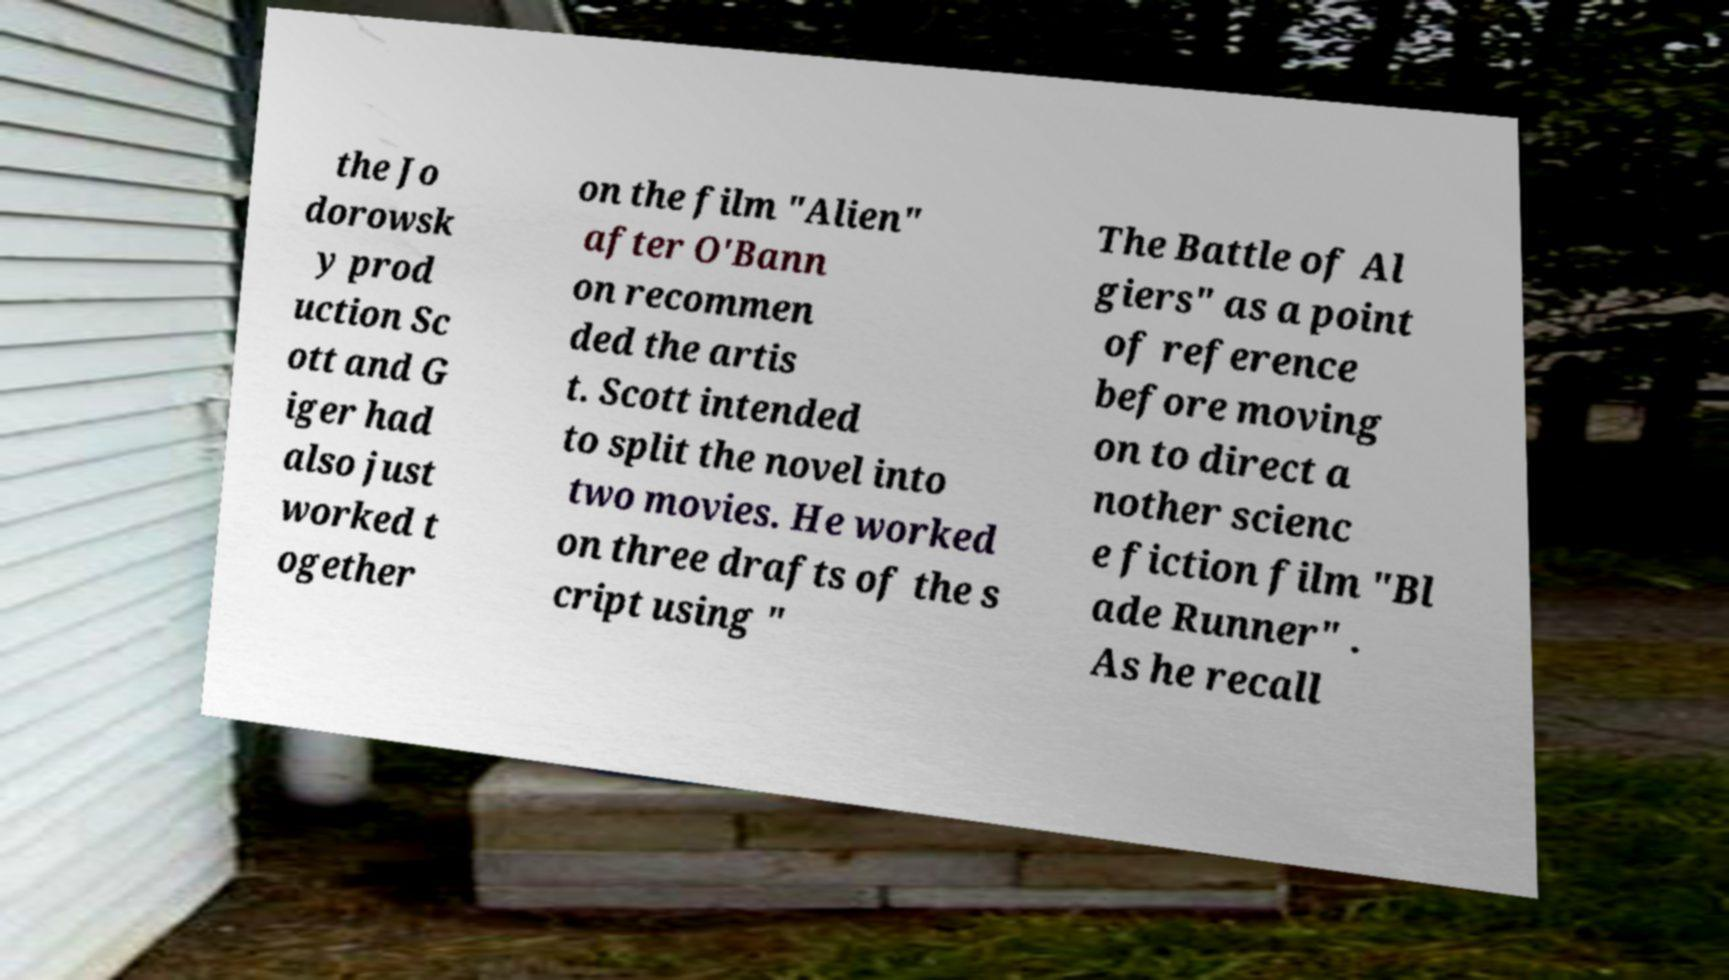What messages or text are displayed in this image? I need them in a readable, typed format. the Jo dorowsk y prod uction Sc ott and G iger had also just worked t ogether on the film "Alien" after O'Bann on recommen ded the artis t. Scott intended to split the novel into two movies. He worked on three drafts of the s cript using " The Battle of Al giers" as a point of reference before moving on to direct a nother scienc e fiction film "Bl ade Runner" . As he recall 